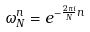<formula> <loc_0><loc_0><loc_500><loc_500>\omega _ { N } ^ { n } = e ^ { - \frac { 2 \pi i } { N } n }</formula> 